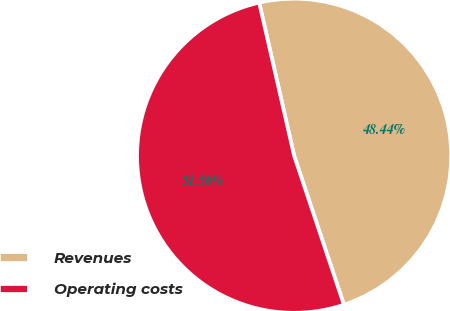Convert chart to OTSL. <chart><loc_0><loc_0><loc_500><loc_500><pie_chart><fcel>Revenues<fcel>Operating costs<nl><fcel>48.44%<fcel>51.56%<nl></chart> 